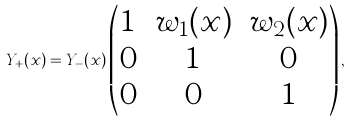<formula> <loc_0><loc_0><loc_500><loc_500>Y _ { + } ( x ) = Y _ { - } ( x ) \begin{pmatrix} 1 & w _ { 1 } ( x ) & w _ { 2 } ( x ) \\ 0 & 1 & 0 \\ 0 & 0 & 1 \end{pmatrix} ,</formula> 